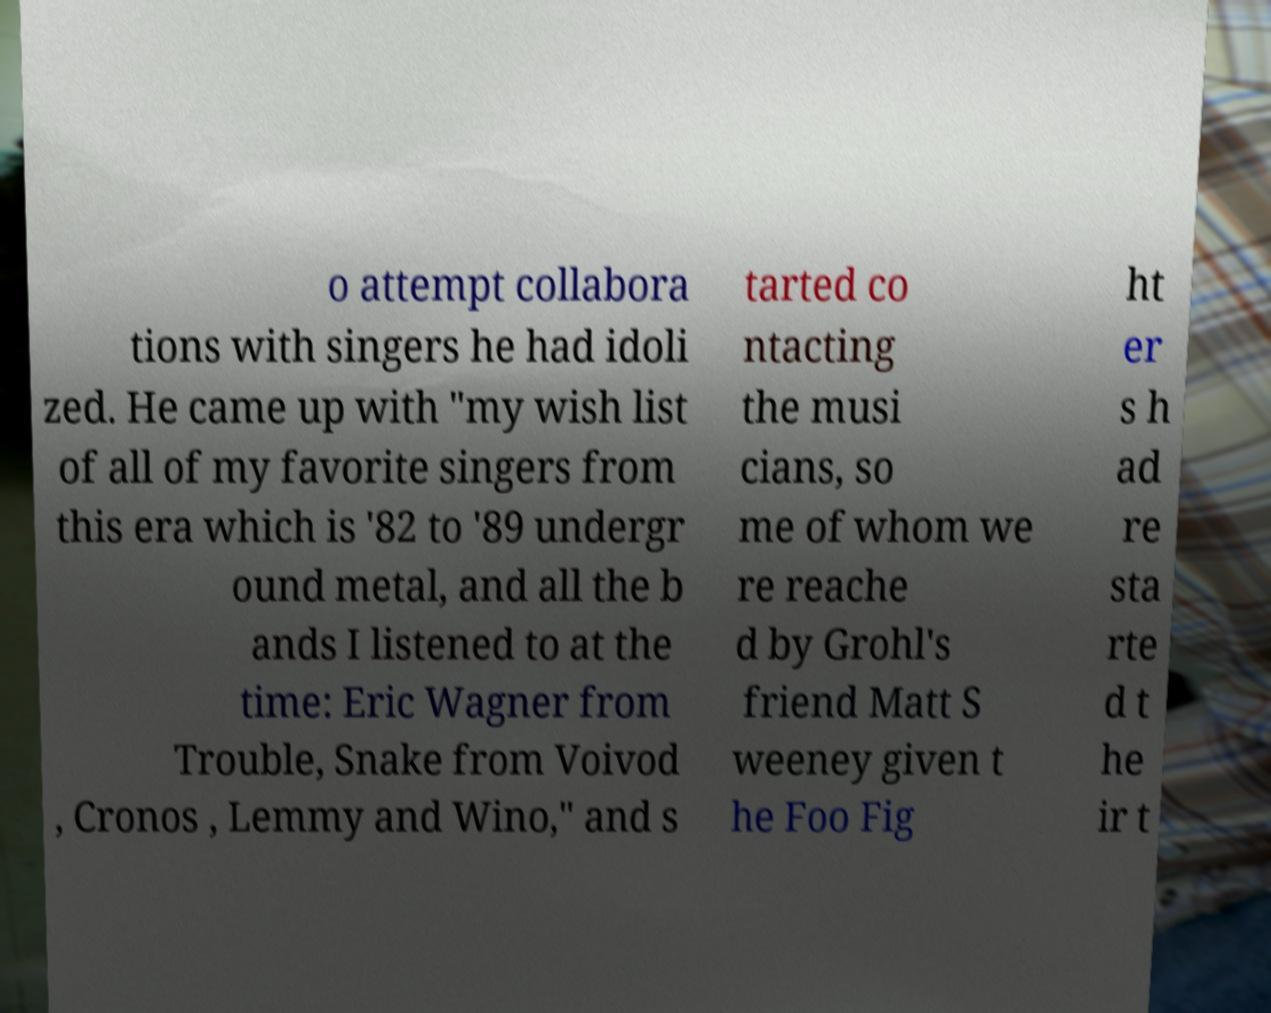Please identify and transcribe the text found in this image. o attempt collabora tions with singers he had idoli zed. He came up with "my wish list of all of my favorite singers from this era which is '82 to '89 undergr ound metal, and all the b ands I listened to at the time: Eric Wagner from Trouble, Snake from Voivod , Cronos , Lemmy and Wino," and s tarted co ntacting the musi cians, so me of whom we re reache d by Grohl's friend Matt S weeney given t he Foo Fig ht er s h ad re sta rte d t he ir t 